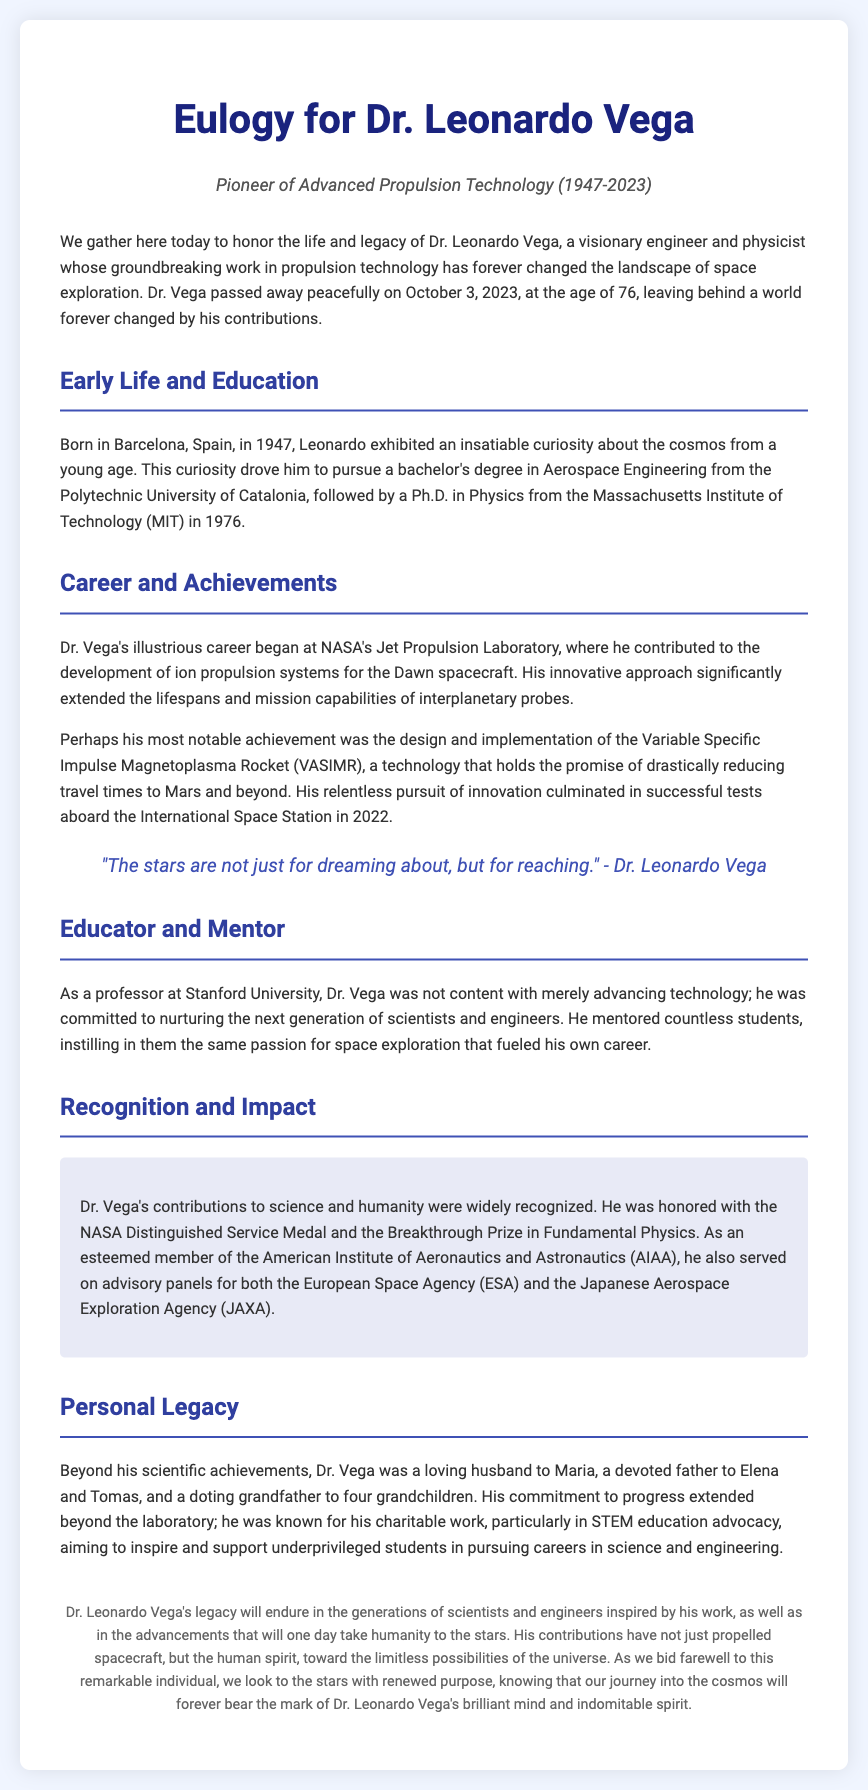What year was Dr. Leonardo Vega born? The document states that he was born in Barcelona, Spain, in 1947.
Answer: 1947 What is the name of the propulsion technology Dr. Vega designed? The document mentions that he designed the Variable Specific Impulse Magnetoplasma Rocket (VASIMR).
Answer: VASIMR How old was Dr. Leonardo Vega when he passed away? The document indicates that he passed away at the age of 76.
Answer: 76 What significant medal did Dr. Vega receive from NASA? The document highlights that Dr. Vega was honored with the NASA Distinguished Service Medal.
Answer: NASA Distinguished Service Medal What was Dr. Vega's primary occupation at Stanford University? The document refers to Dr. Vega as a professor who mentored students.
Answer: Professor What did Dr. Vega emphasize in his charitable work? The document mentions that he was focused on STEM education advocacy for underprivileged students.
Answer: STEM education advocacy Which space agencies did Dr. Vega serve on advisory panels for? The document lists both the European Space Agency and the Japanese Aerospace Exploration Agency.
Answer: European Space Agency and JAXA What quote is attributed to Dr. Leonardo Vega? The document shares Dr. Vega's quote: "The stars are not just for dreaming about, but for reaching."
Answer: "The stars are not just for dreaming about, but for reaching." 